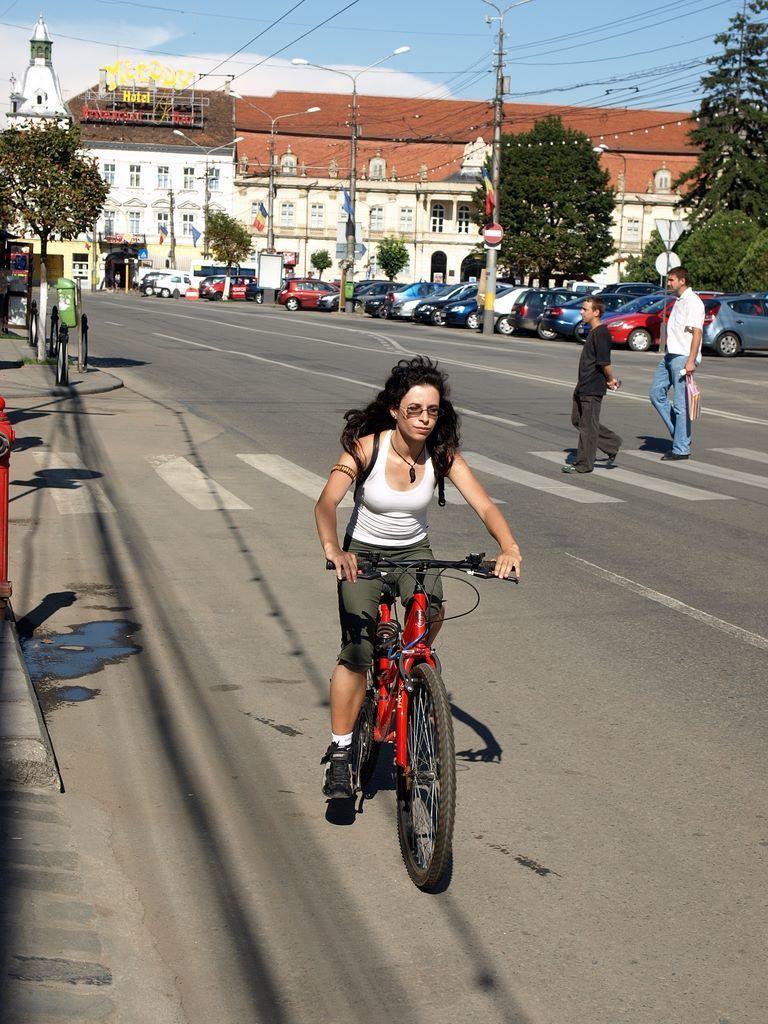Can you describe this image briefly? It seems to be the image is outside of the city. In the image there is a woman sitting on bicycle and riding it, and on right side there are two men's walking on road. There are also few cars on right side,trees,building,street lights. On left side we can also see trees,dustbin,footpath and top there are some electrical wires and sky at bottom there is a road which is in black color. 